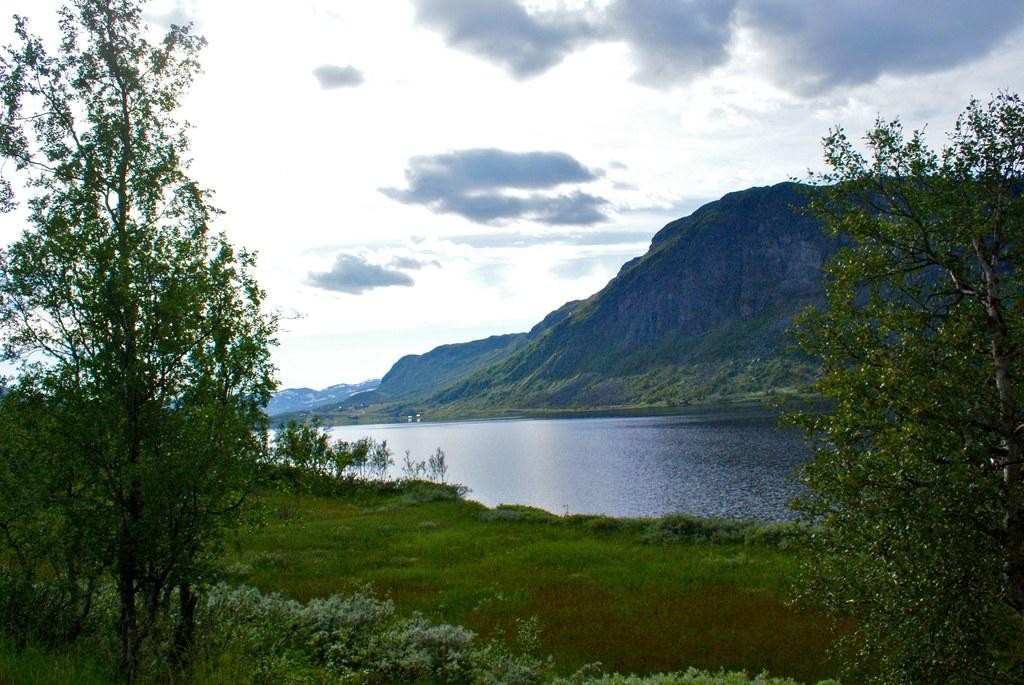What type of vegetation is present in the image? There is grass in the image. What other natural elements can be seen in the image? There are trees and water visible in the image. What type of geographical feature is present in the image? There are mountains in the image. What can be seen in the sky in the image? There are clouds in the image, and the sky is visible. What type of veil is draped over the shop in the image? There is no shop or veil present in the image. Can you tell me how many dogs are visible in the image? There are no dogs present in the image. 